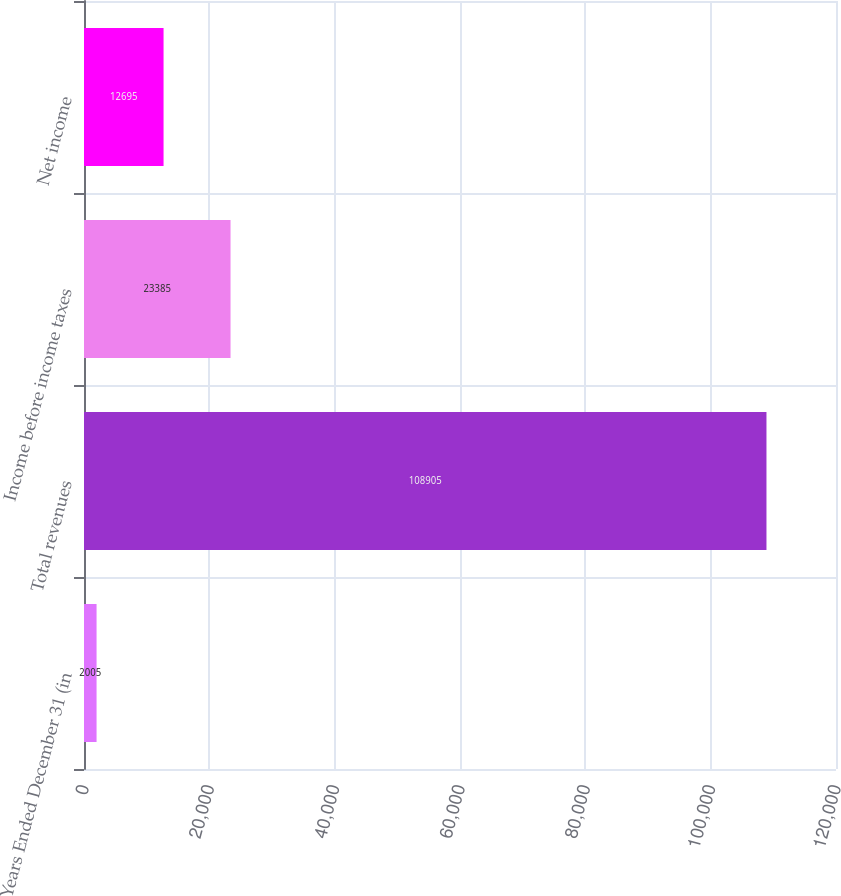<chart> <loc_0><loc_0><loc_500><loc_500><bar_chart><fcel>Years Ended December 31 (in<fcel>Total revenues<fcel>Income before income taxes<fcel>Net income<nl><fcel>2005<fcel>108905<fcel>23385<fcel>12695<nl></chart> 